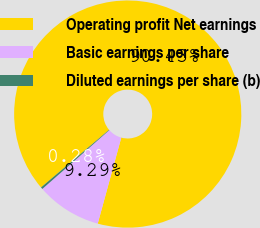<chart> <loc_0><loc_0><loc_500><loc_500><pie_chart><fcel>Operating profit Net earnings<fcel>Basic earnings per share<fcel>Diluted earnings per share (b)<nl><fcel>90.43%<fcel>9.29%<fcel>0.28%<nl></chart> 